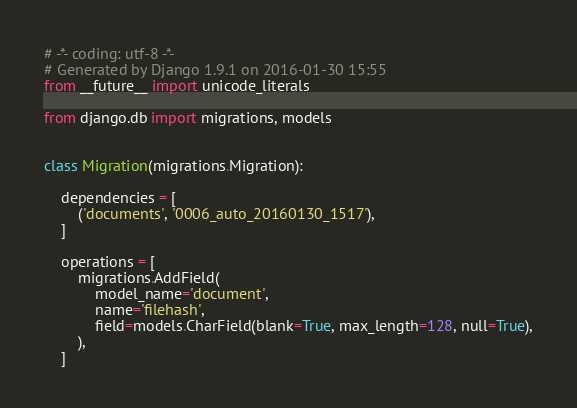Convert code to text. <code><loc_0><loc_0><loc_500><loc_500><_Python_># -*- coding: utf-8 -*-
# Generated by Django 1.9.1 on 2016-01-30 15:55
from __future__ import unicode_literals

from django.db import migrations, models


class Migration(migrations.Migration):

    dependencies = [
        ('documents', '0006_auto_20160130_1517'),
    ]

    operations = [
        migrations.AddField(
            model_name='document',
            name='filehash',
            field=models.CharField(blank=True, max_length=128, null=True),
        ),
    ]
</code> 